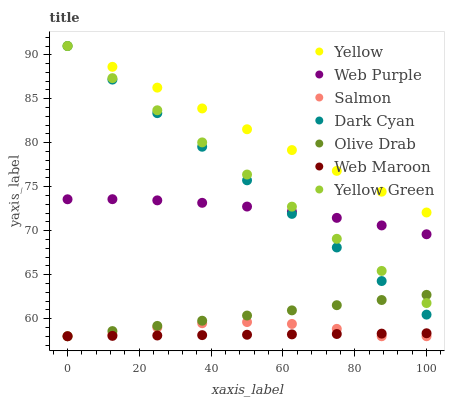Does Web Maroon have the minimum area under the curve?
Answer yes or no. Yes. Does Yellow have the maximum area under the curve?
Answer yes or no. Yes. Does Salmon have the minimum area under the curve?
Answer yes or no. No. Does Salmon have the maximum area under the curve?
Answer yes or no. No. Is Web Maroon the smoothest?
Answer yes or no. Yes. Is Salmon the roughest?
Answer yes or no. Yes. Is Salmon the smoothest?
Answer yes or no. No. Is Web Maroon the roughest?
Answer yes or no. No. Does Salmon have the lowest value?
Answer yes or no. Yes. Does Yellow have the lowest value?
Answer yes or no. No. Does Dark Cyan have the highest value?
Answer yes or no. Yes. Does Salmon have the highest value?
Answer yes or no. No. Is Web Purple less than Yellow?
Answer yes or no. Yes. Is Web Purple greater than Web Maroon?
Answer yes or no. Yes. Does Yellow Green intersect Yellow?
Answer yes or no. Yes. Is Yellow Green less than Yellow?
Answer yes or no. No. Is Yellow Green greater than Yellow?
Answer yes or no. No. Does Web Purple intersect Yellow?
Answer yes or no. No. 